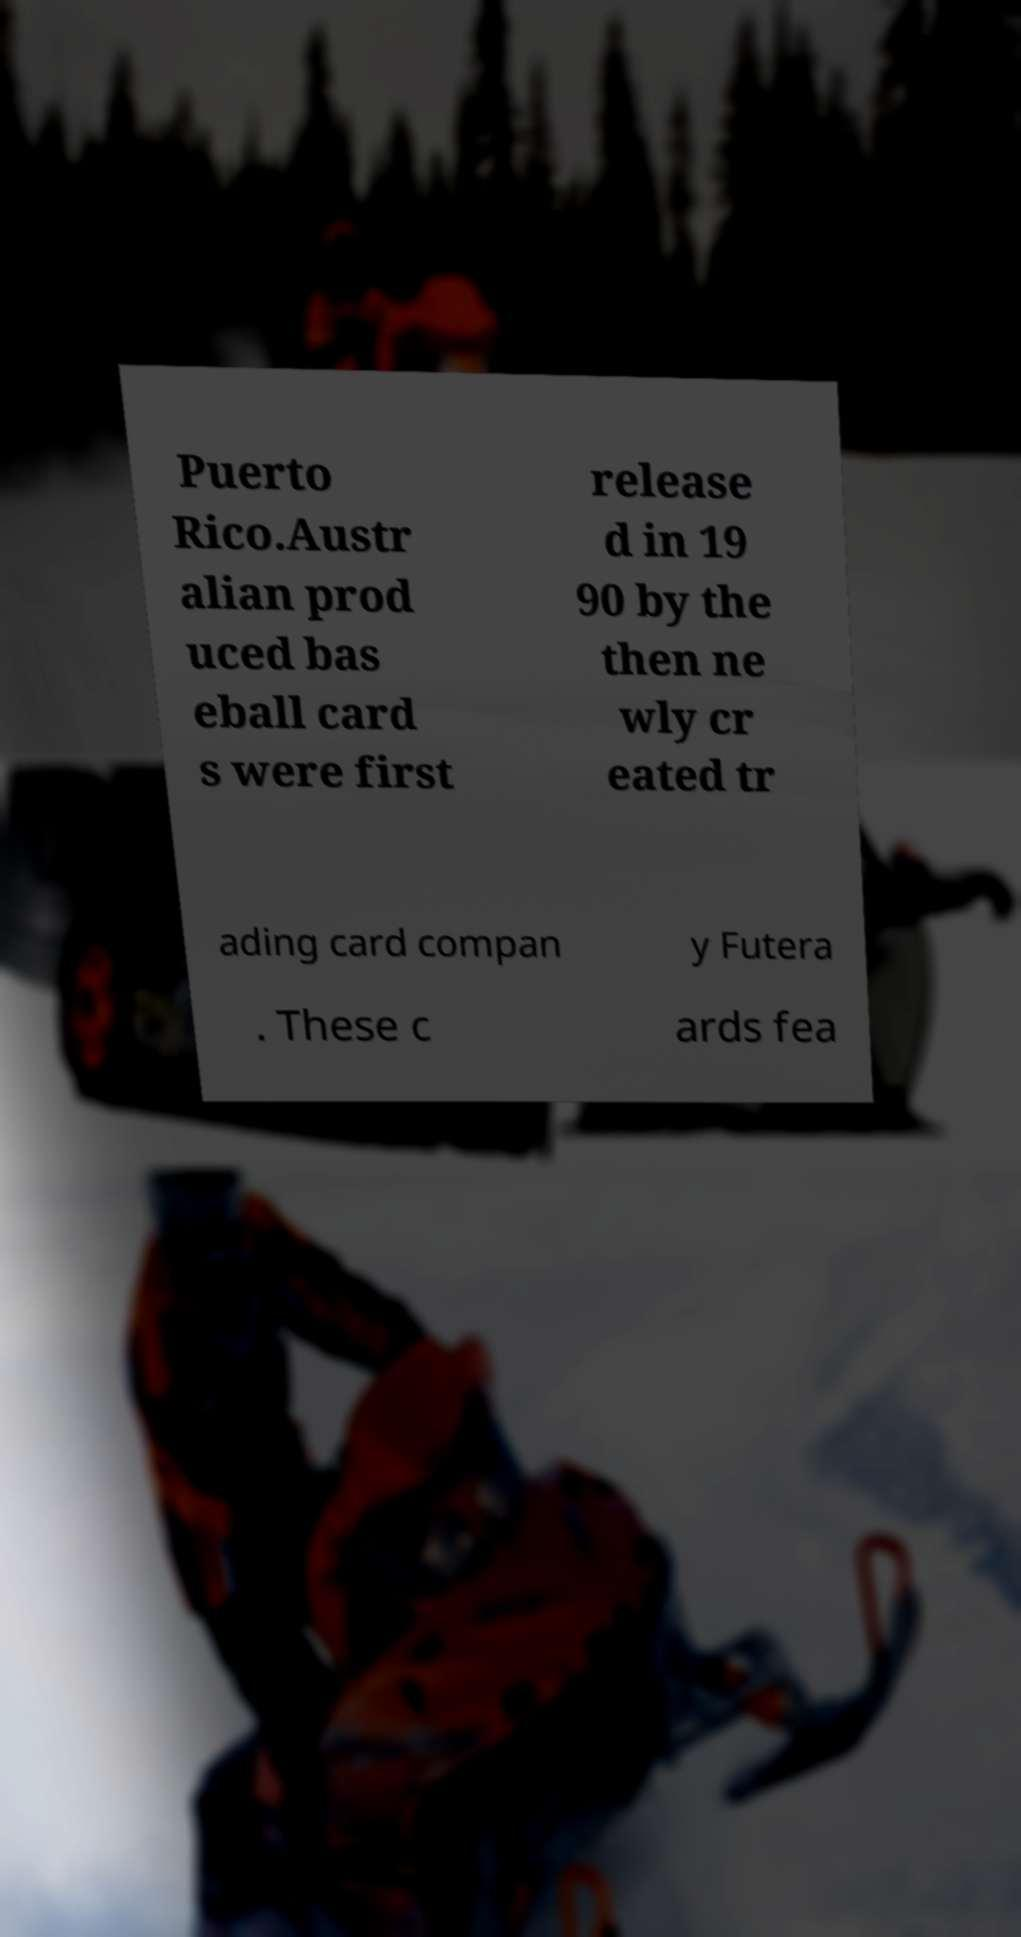Can you accurately transcribe the text from the provided image for me? Puerto Rico.Austr alian prod uced bas eball card s were first release d in 19 90 by the then ne wly cr eated tr ading card compan y Futera . These c ards fea 